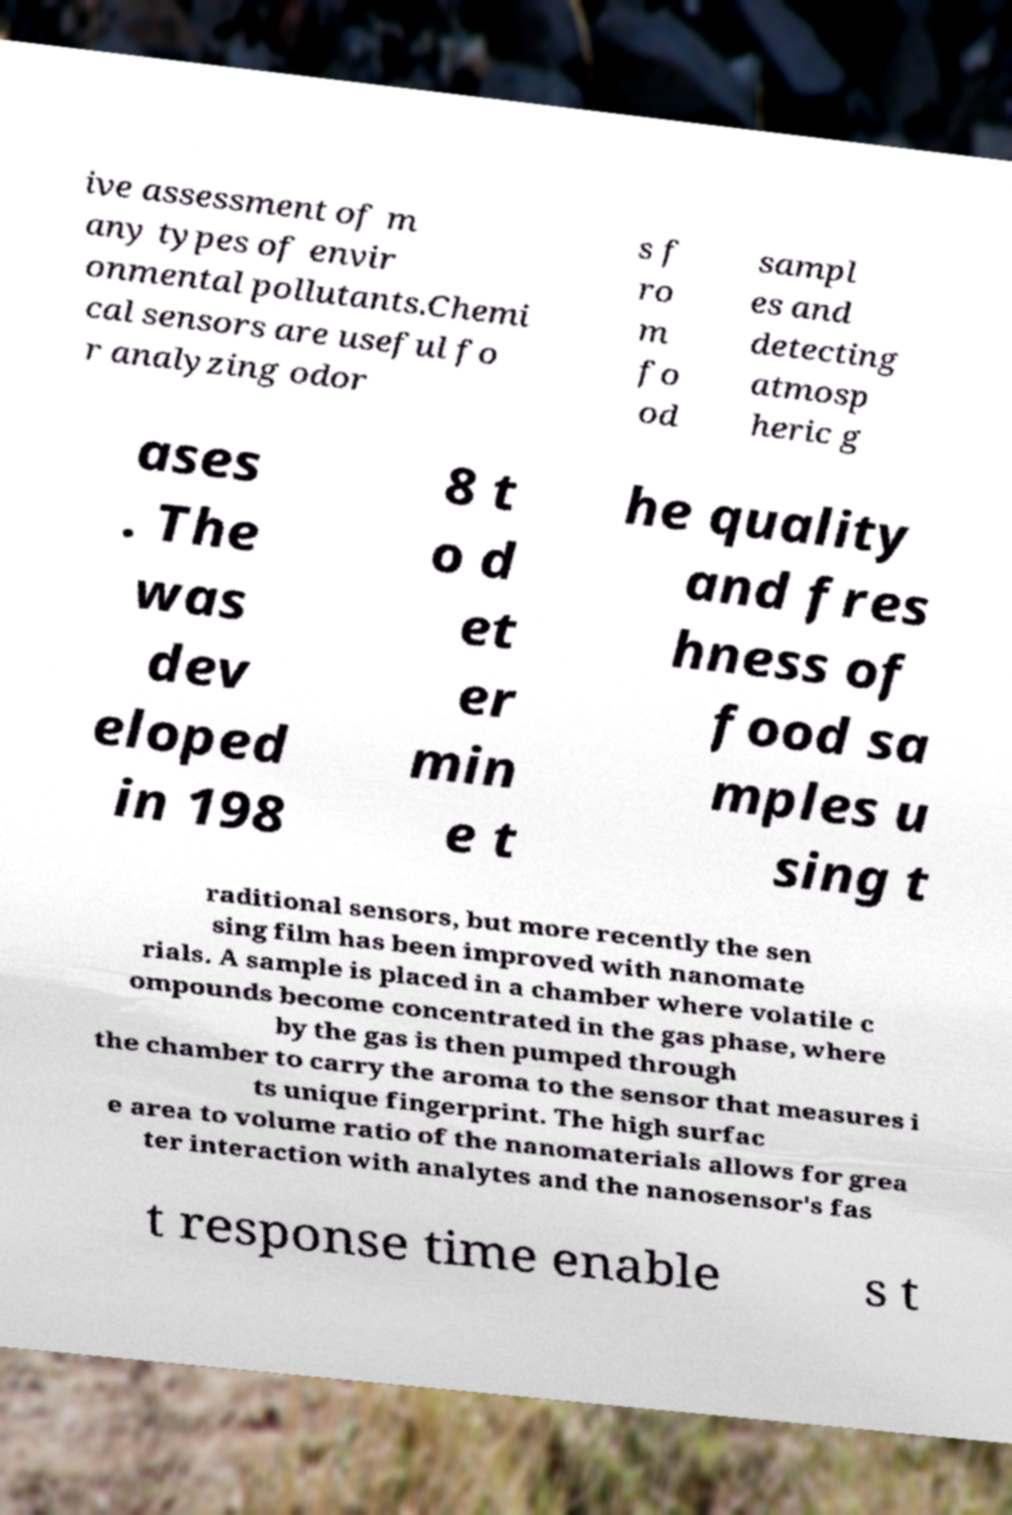Can you accurately transcribe the text from the provided image for me? ive assessment of m any types of envir onmental pollutants.Chemi cal sensors are useful fo r analyzing odor s f ro m fo od sampl es and detecting atmosp heric g ases . The was dev eloped in 198 8 t o d et er min e t he quality and fres hness of food sa mples u sing t raditional sensors, but more recently the sen sing film has been improved with nanomate rials. A sample is placed in a chamber where volatile c ompounds become concentrated in the gas phase, where by the gas is then pumped through the chamber to carry the aroma to the sensor that measures i ts unique fingerprint. The high surfac e area to volume ratio of the nanomaterials allows for grea ter interaction with analytes and the nanosensor's fas t response time enable s t 